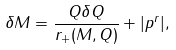<formula> <loc_0><loc_0><loc_500><loc_500>\delta M = \frac { Q \delta Q } { r _ { + } ( M , Q ) } + | p ^ { r } | ,</formula> 